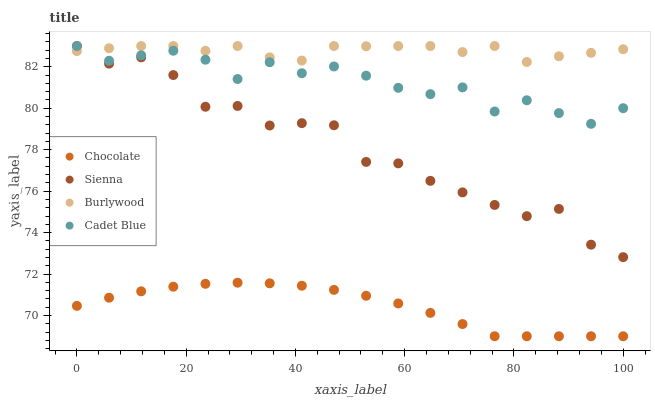Does Chocolate have the minimum area under the curve?
Answer yes or no. Yes. Does Burlywood have the maximum area under the curve?
Answer yes or no. Yes. Does Cadet Blue have the minimum area under the curve?
Answer yes or no. No. Does Cadet Blue have the maximum area under the curve?
Answer yes or no. No. Is Chocolate the smoothest?
Answer yes or no. Yes. Is Sienna the roughest?
Answer yes or no. Yes. Is Burlywood the smoothest?
Answer yes or no. No. Is Burlywood the roughest?
Answer yes or no. No. Does Chocolate have the lowest value?
Answer yes or no. Yes. Does Cadet Blue have the lowest value?
Answer yes or no. No. Does Cadet Blue have the highest value?
Answer yes or no. Yes. Does Chocolate have the highest value?
Answer yes or no. No. Is Chocolate less than Burlywood?
Answer yes or no. Yes. Is Cadet Blue greater than Chocolate?
Answer yes or no. Yes. Does Sienna intersect Burlywood?
Answer yes or no. Yes. Is Sienna less than Burlywood?
Answer yes or no. No. Is Sienna greater than Burlywood?
Answer yes or no. No. Does Chocolate intersect Burlywood?
Answer yes or no. No. 